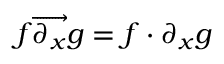Convert formula to latex. <formula><loc_0><loc_0><loc_500><loc_500>f { \overrightarrow { \partial _ { x } } } g = f \cdot \partial _ { x } g</formula> 